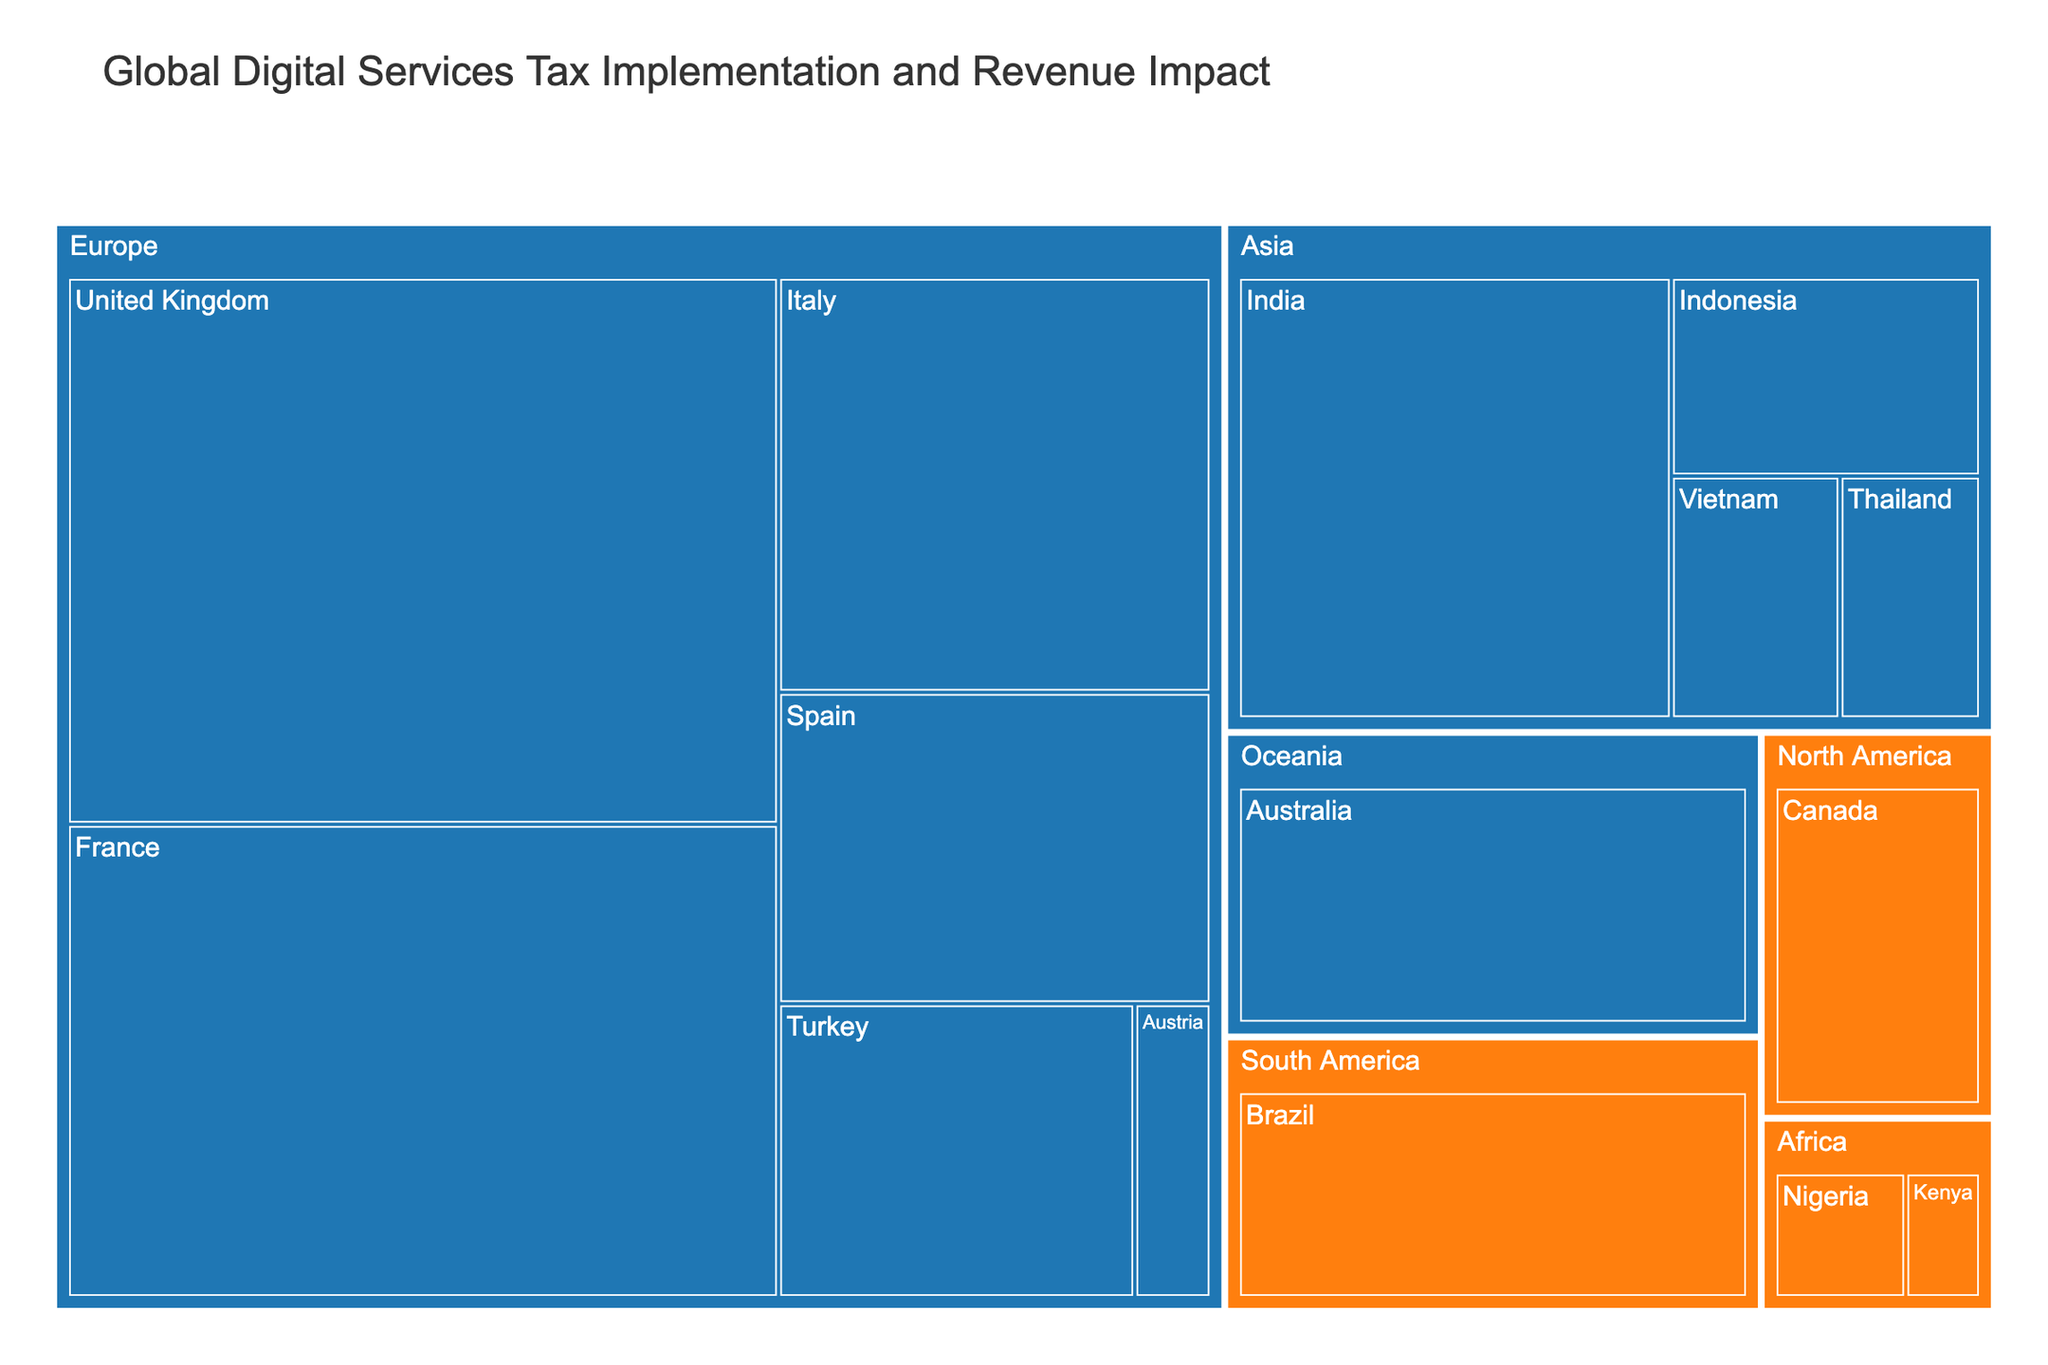What's the title of the treemap? The title is usually located at the top of the figure and provides a description of the data being visualized.
Answer: Global Digital Services Tax Implementation and Revenue Impact Which country in Europe has the highest revenue impact? In the treemap, regions and countries are color-coded. By locating Europe and then finding the country with the largest area within that region, we can determine the country with the highest revenue impact.
Answer: United Kingdom How many countries have implemented the digital services tax? Countries are color-coded by their DST implementation status. By counting the countries in the color associated with 'Implemented', we get the total number.
Answer: 10 What is the combined revenue impact for the Asian countries that have implemented the DST? Locate the Asian region, identify countries marked as 'Implemented', and sum their revenue impact values: India (280) + Indonesia (90) + Thailand (50) + Vietnam (60).
Answer: 480 Million USD Which region has the most countries with proposed DST? For each region, count the countries with the color associated with 'Proposed'. The region with the highest count has the most proposed DST.
Answer: Africa How does the revenue impact of France compare to India? Locate France and India on the treemap. Compare their revenue impact values. France has 450 million USD and India has 280 million USD. France's revenue impact is higher.
Answer: France’s revenue impact is higher What is the total revenue impact of all European countries? Sum the revenue impact values for all European countries listed in the data: France (450) + United Kingdom (520) + Italy (240) + Spain (180) + Austria (30) + Turkey (140).
Answer: 1560 Million USD Which country in Oceania has implemented the digital services tax? Find the Oceania region on the treemap and check the DST implementation status for the country listed.
Answer: Australia What is the minimum revenue impact among all countries that have implemented the DST? Look at the countries with 'Implemented' status and find the one with the smallest revenue impact value.
Answer: Austria (30 Million USD) How does the sum of revenue impacts for countries with proposed DST compare to Brazil's individual impact? First, sum the revenue impacts of countries with proposed DST: Kenya (20) + Nigeria (35) + Brazil (180) + Canada (110). Compare this sum to Brazil's individual impact (180). The sum is 345, which is higher than Brazil’s 180.
Answer: The sum (345 Million USD) is higher than Brazil’s impact 